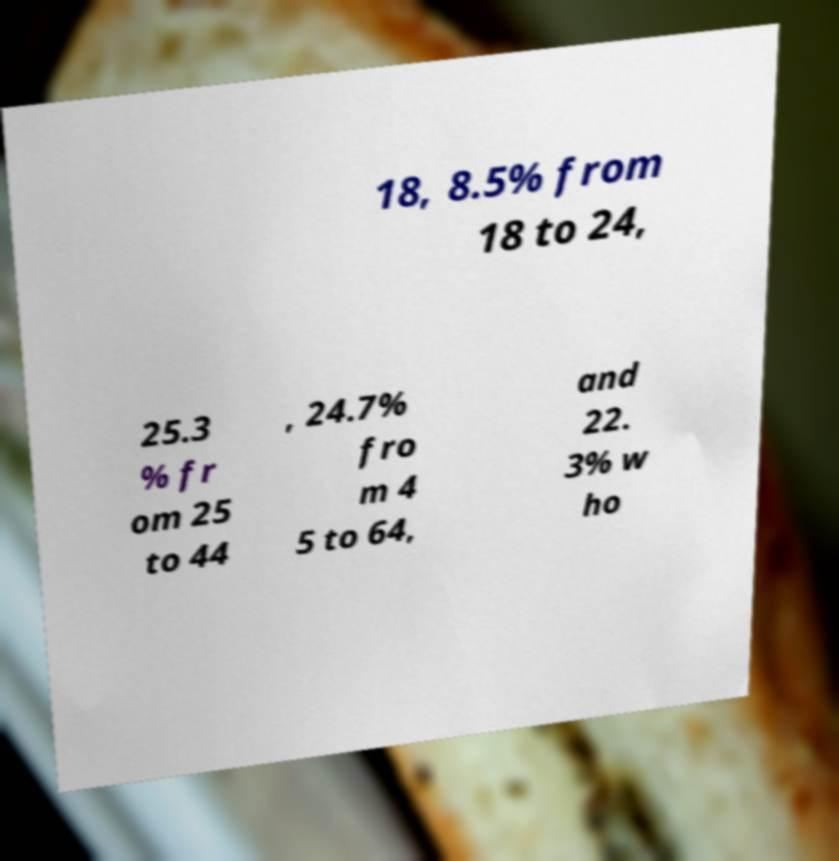What messages or text are displayed in this image? I need them in a readable, typed format. 18, 8.5% from 18 to 24, 25.3 % fr om 25 to 44 , 24.7% fro m 4 5 to 64, and 22. 3% w ho 